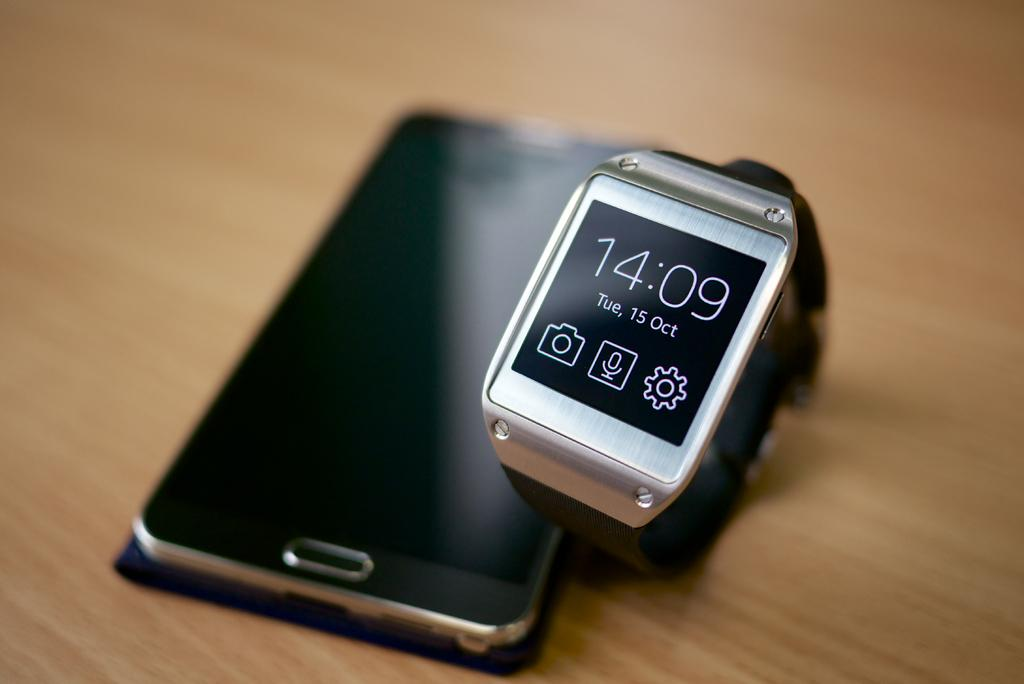<image>
Present a compact description of the photo's key features. Black watch that says 14:09 next to a black phone. 